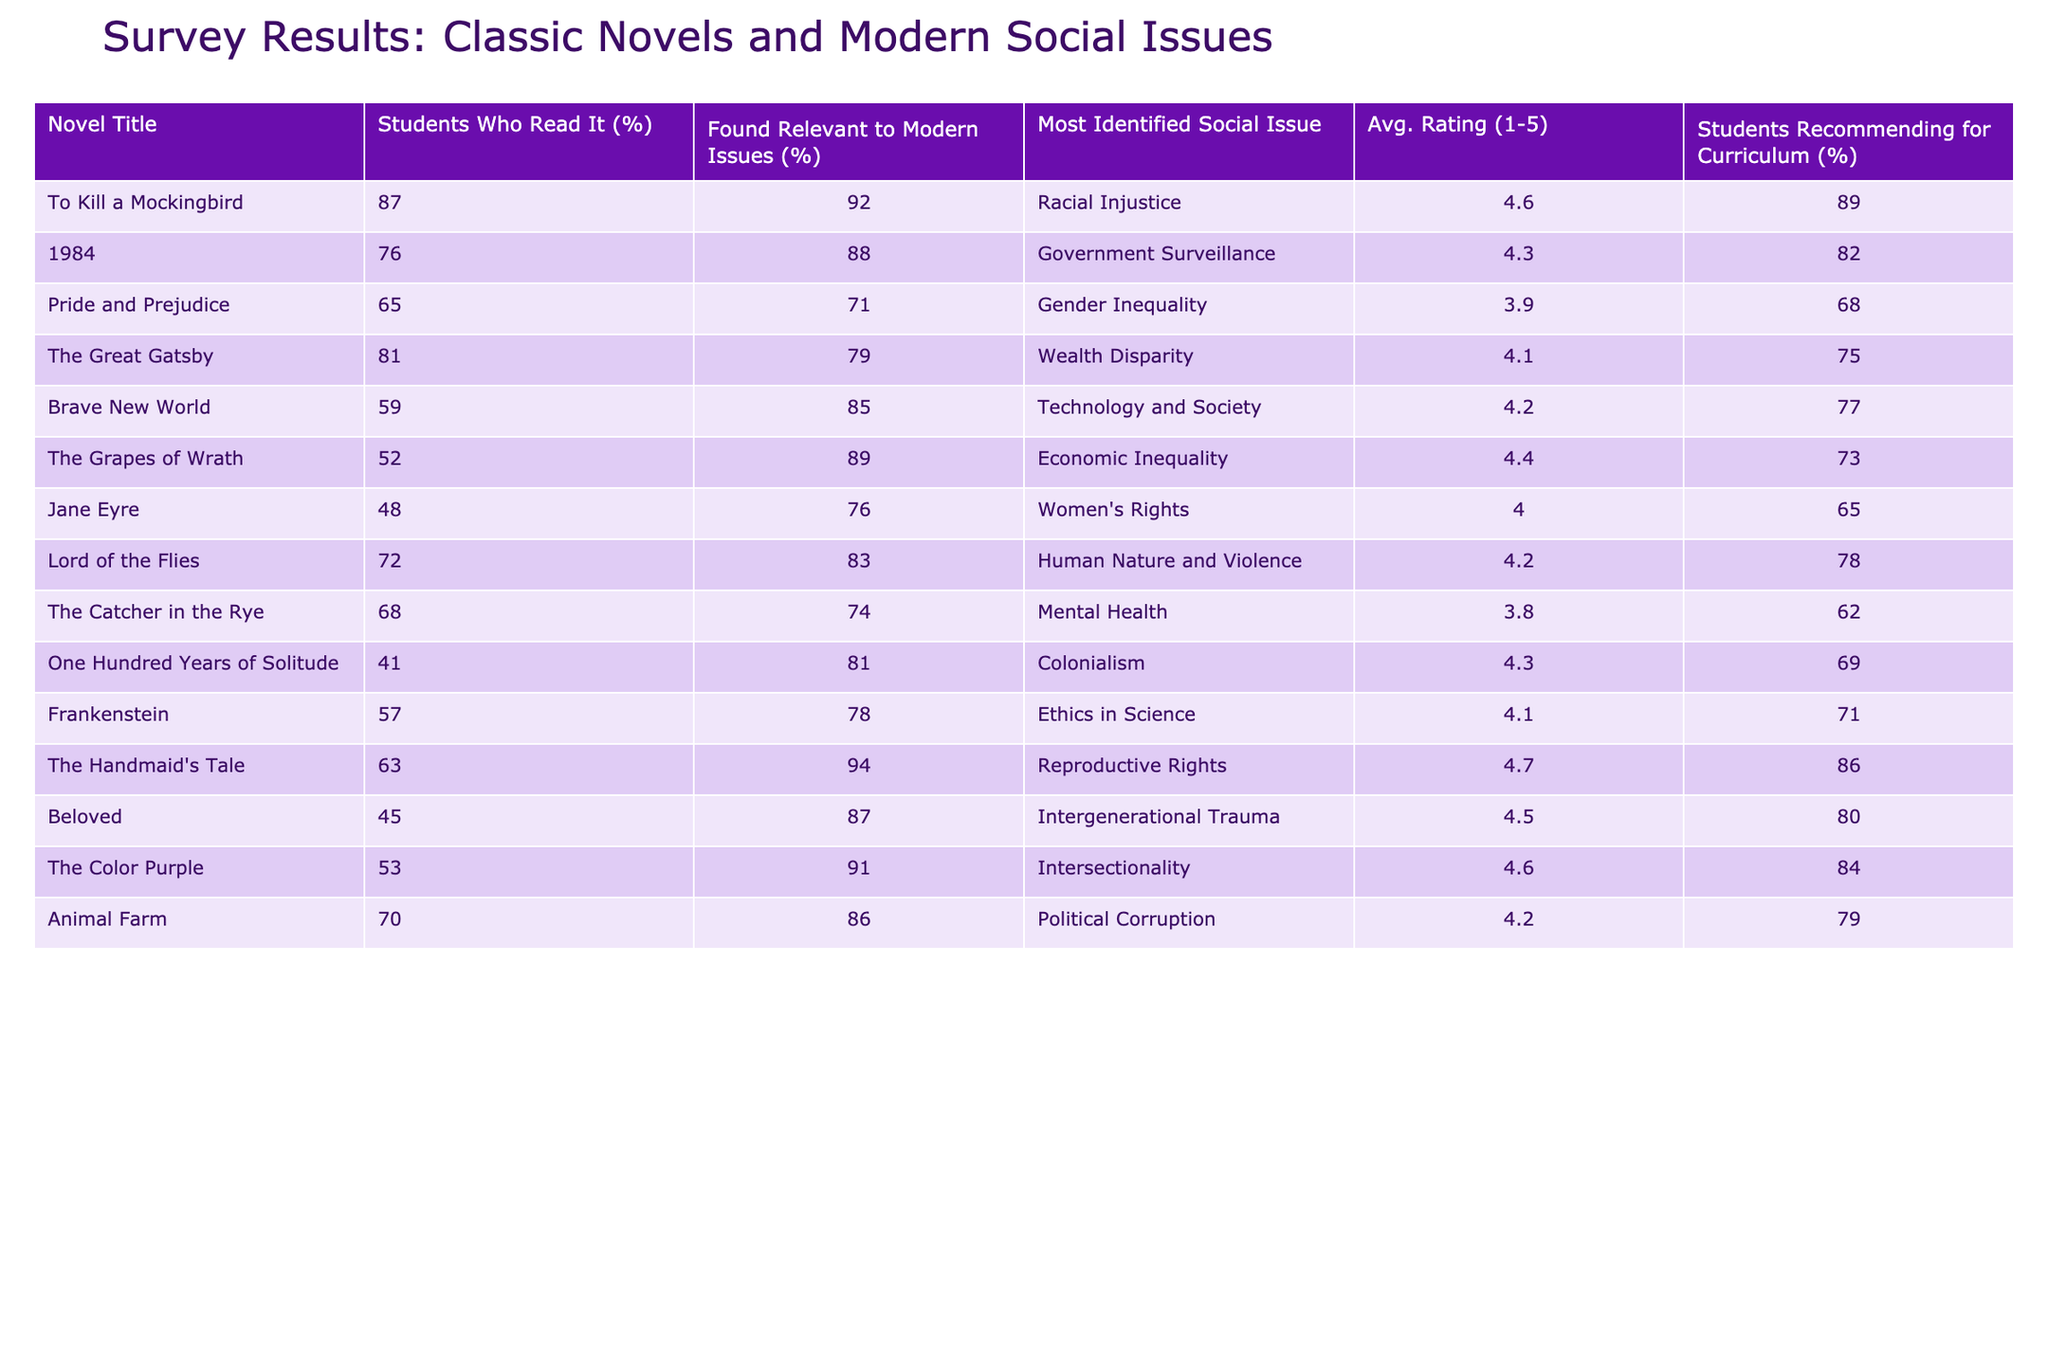What's the average rating for "To Kill a Mockingbird"? The table shows that the average rating for "To Kill a Mockingbird" is listed as 4.6.
Answer: 4.6 How many students found "Pride and Prejudice" relevant to modern issues? According to the table, 71% of students found "Pride and Prejudice" relevant to modern issues.
Answer: 71% Which novel had the highest percentage of students recommending it for the curriculum? The table indicates that "To Kill a Mockingbird" has 89% of students recommending it for the curriculum, which is the highest percentage among the listed novels.
Answer: 89% What is the difference in the percentage of students who found "1984" relevant to modern issues compared to "The Grapes of Wrath"? "1984" has 88% and "The Grapes of Wrath" has 89%. The difference is 89 - 88 = 1%.
Answer: 1% Did more students read "The Handmaid's Tale" or "Jane Eyre"? The table shows that 63% of students read "The Handmaid's Tale" while only 48% read "Jane Eyre," indicating that more students read "The Handmaid's Tale."
Answer: Yes Which social issue was most commonly identified by students for "The Color Purple"? The table states that the most identified social issue for "The Color Purple" is Intersectionality.
Answer: Intersectionality Calculate the average rating for all novels that address economic issues. The novels that address economic issues are "The Grapes of Wrath" (4.4) and "The Great Gatsby" (4.1). The average rating is (4.4 + 4.1) / 2 = 4.25.
Answer: 4.25 Is there a correlation between the percentage of students who found a novel relevant to modern issues and the average rating it received? To determine this, we compare the relevant percentages and average ratings. For example, "The Handmaid's Tale" has 94% relevance and a 4.7 rating, while "Pride and Prejudice" has 71% relevance and a 3.9 rating. This indicates a positive trend, suggesting correlation.
Answer: Yes What social issue was identified in "Brave New World," and what was the average rating? The identified social issue in "Brave New World" is Technology and Society, with an average rating of 4.2.
Answer: Technology and Society, 4.2 Which novel had the lowest percentage of students who read it, and what was that percentage? "One Hundred Years of Solitude" had the lowest reading percentage at 41%.
Answer: 41% 